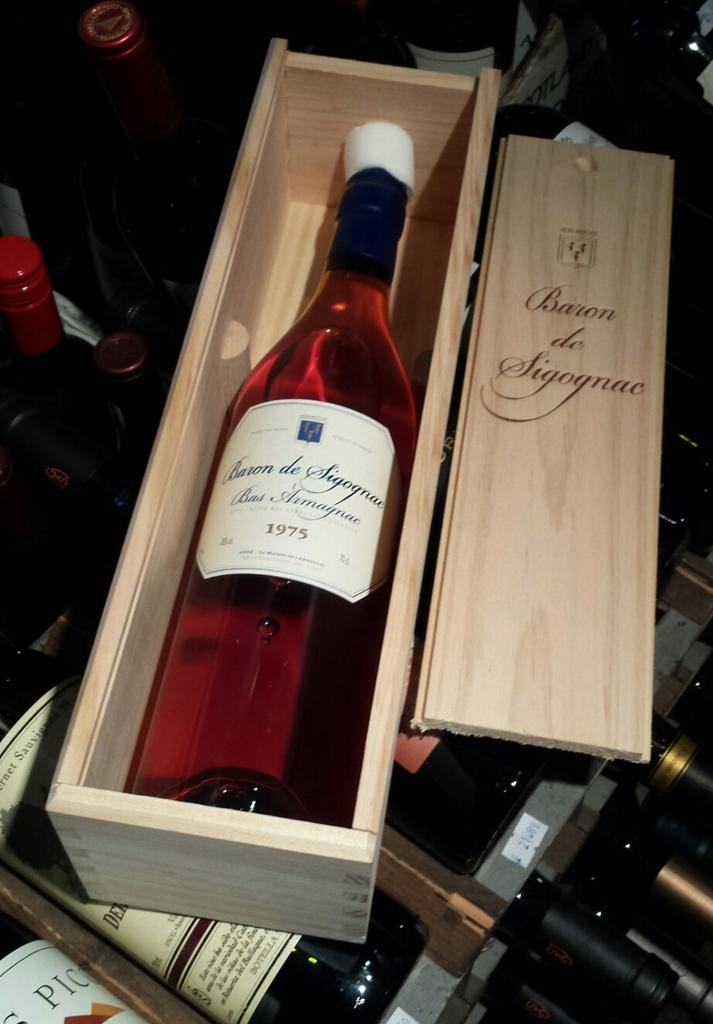<image>
Present a compact description of the photo's key features. a bottle of baron de sigognae wine from 1975 